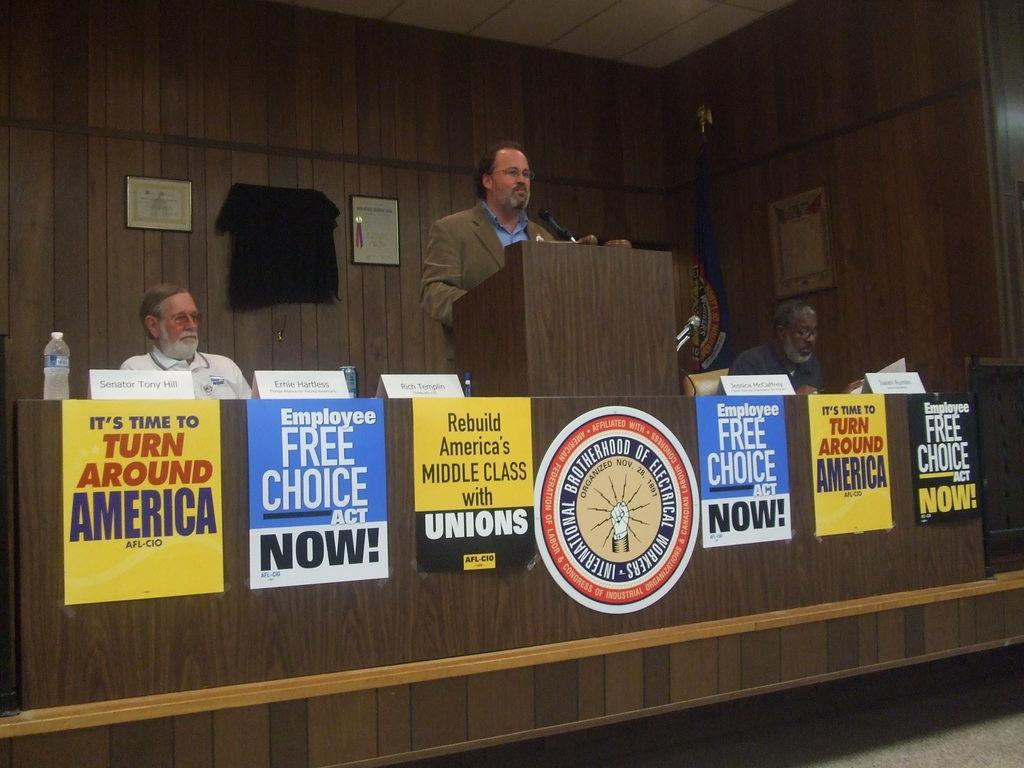What does the sign on the far left say?
Offer a very short reply. It's time to turn around america. What does the sign on the far right say?
Keep it short and to the point. Employee free choice act now. 